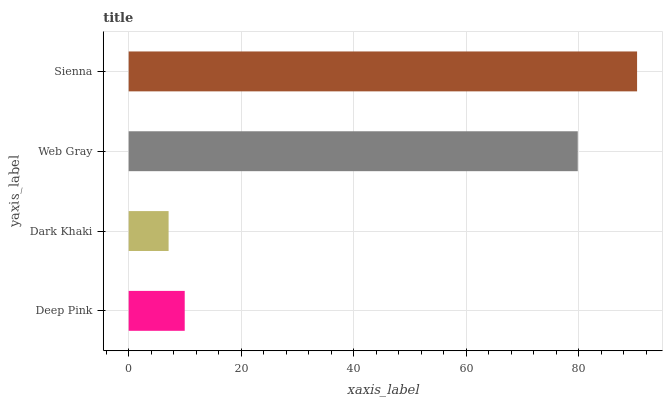Is Dark Khaki the minimum?
Answer yes or no. Yes. Is Sienna the maximum?
Answer yes or no. Yes. Is Web Gray the minimum?
Answer yes or no. No. Is Web Gray the maximum?
Answer yes or no. No. Is Web Gray greater than Dark Khaki?
Answer yes or no. Yes. Is Dark Khaki less than Web Gray?
Answer yes or no. Yes. Is Dark Khaki greater than Web Gray?
Answer yes or no. No. Is Web Gray less than Dark Khaki?
Answer yes or no. No. Is Web Gray the high median?
Answer yes or no. Yes. Is Deep Pink the low median?
Answer yes or no. Yes. Is Deep Pink the high median?
Answer yes or no. No. Is Sienna the low median?
Answer yes or no. No. 